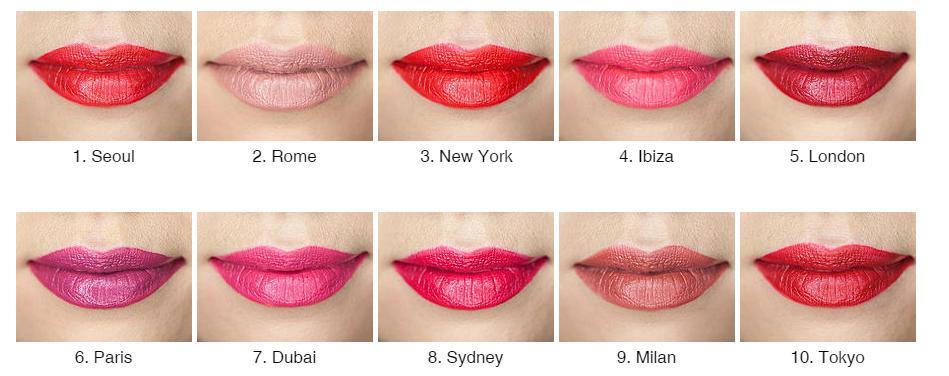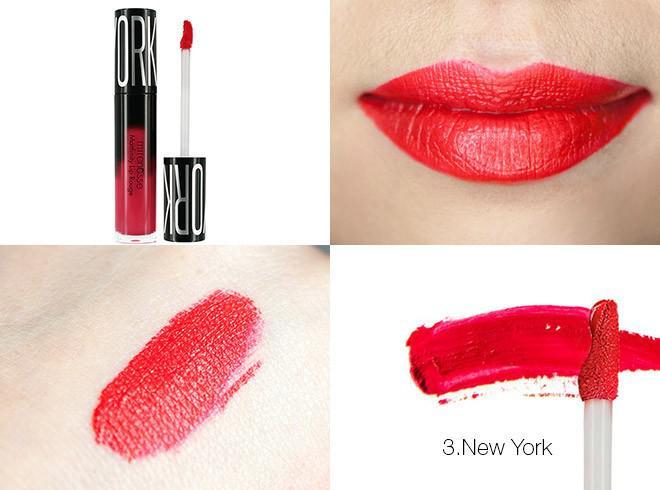The first image is the image on the left, the second image is the image on the right. For the images displayed, is the sentence "There are no tinted lips in the left image only." factually correct? Answer yes or no. No. 